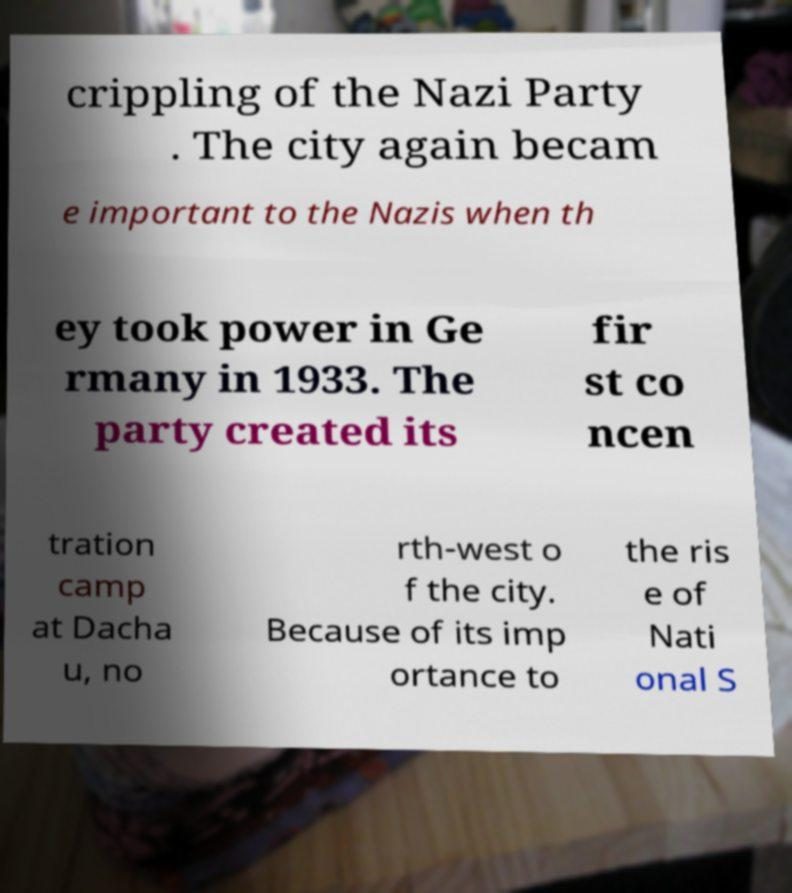There's text embedded in this image that I need extracted. Can you transcribe it verbatim? crippling of the Nazi Party . The city again becam e important to the Nazis when th ey took power in Ge rmany in 1933. The party created its fir st co ncen tration camp at Dacha u, no rth-west o f the city. Because of its imp ortance to the ris e of Nati onal S 